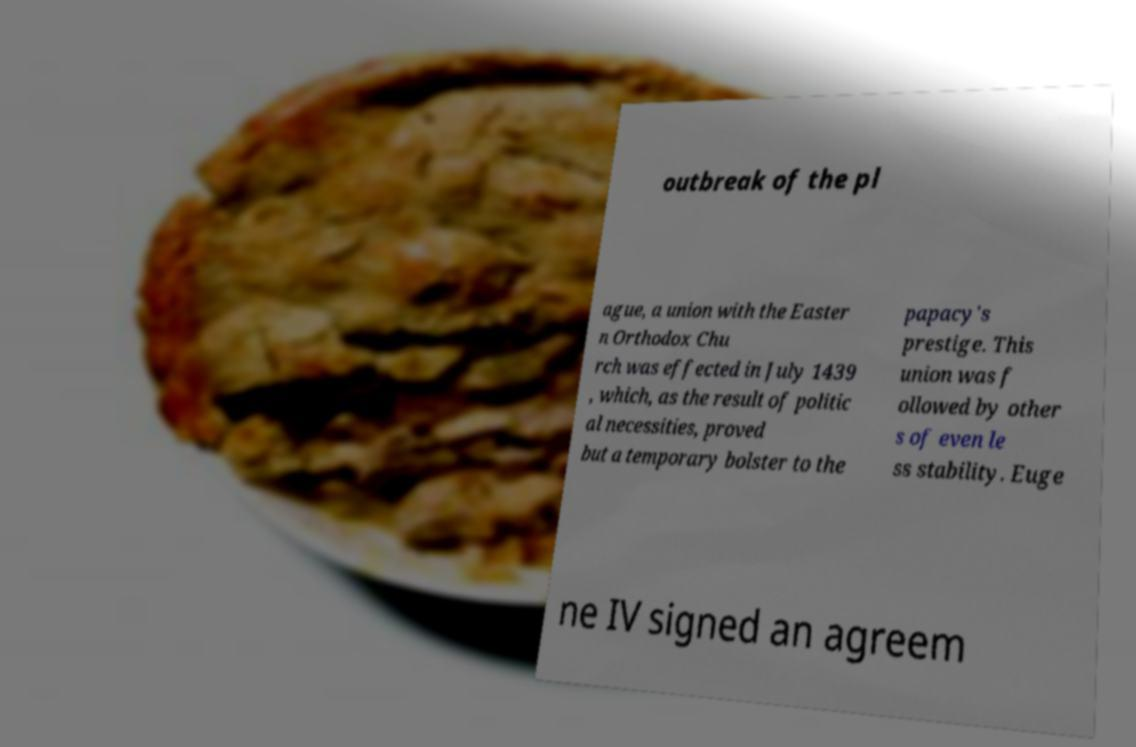Please read and relay the text visible in this image. What does it say? outbreak of the pl ague, a union with the Easter n Orthodox Chu rch was effected in July 1439 , which, as the result of politic al necessities, proved but a temporary bolster to the papacy's prestige. This union was f ollowed by other s of even le ss stability. Euge ne IV signed an agreem 